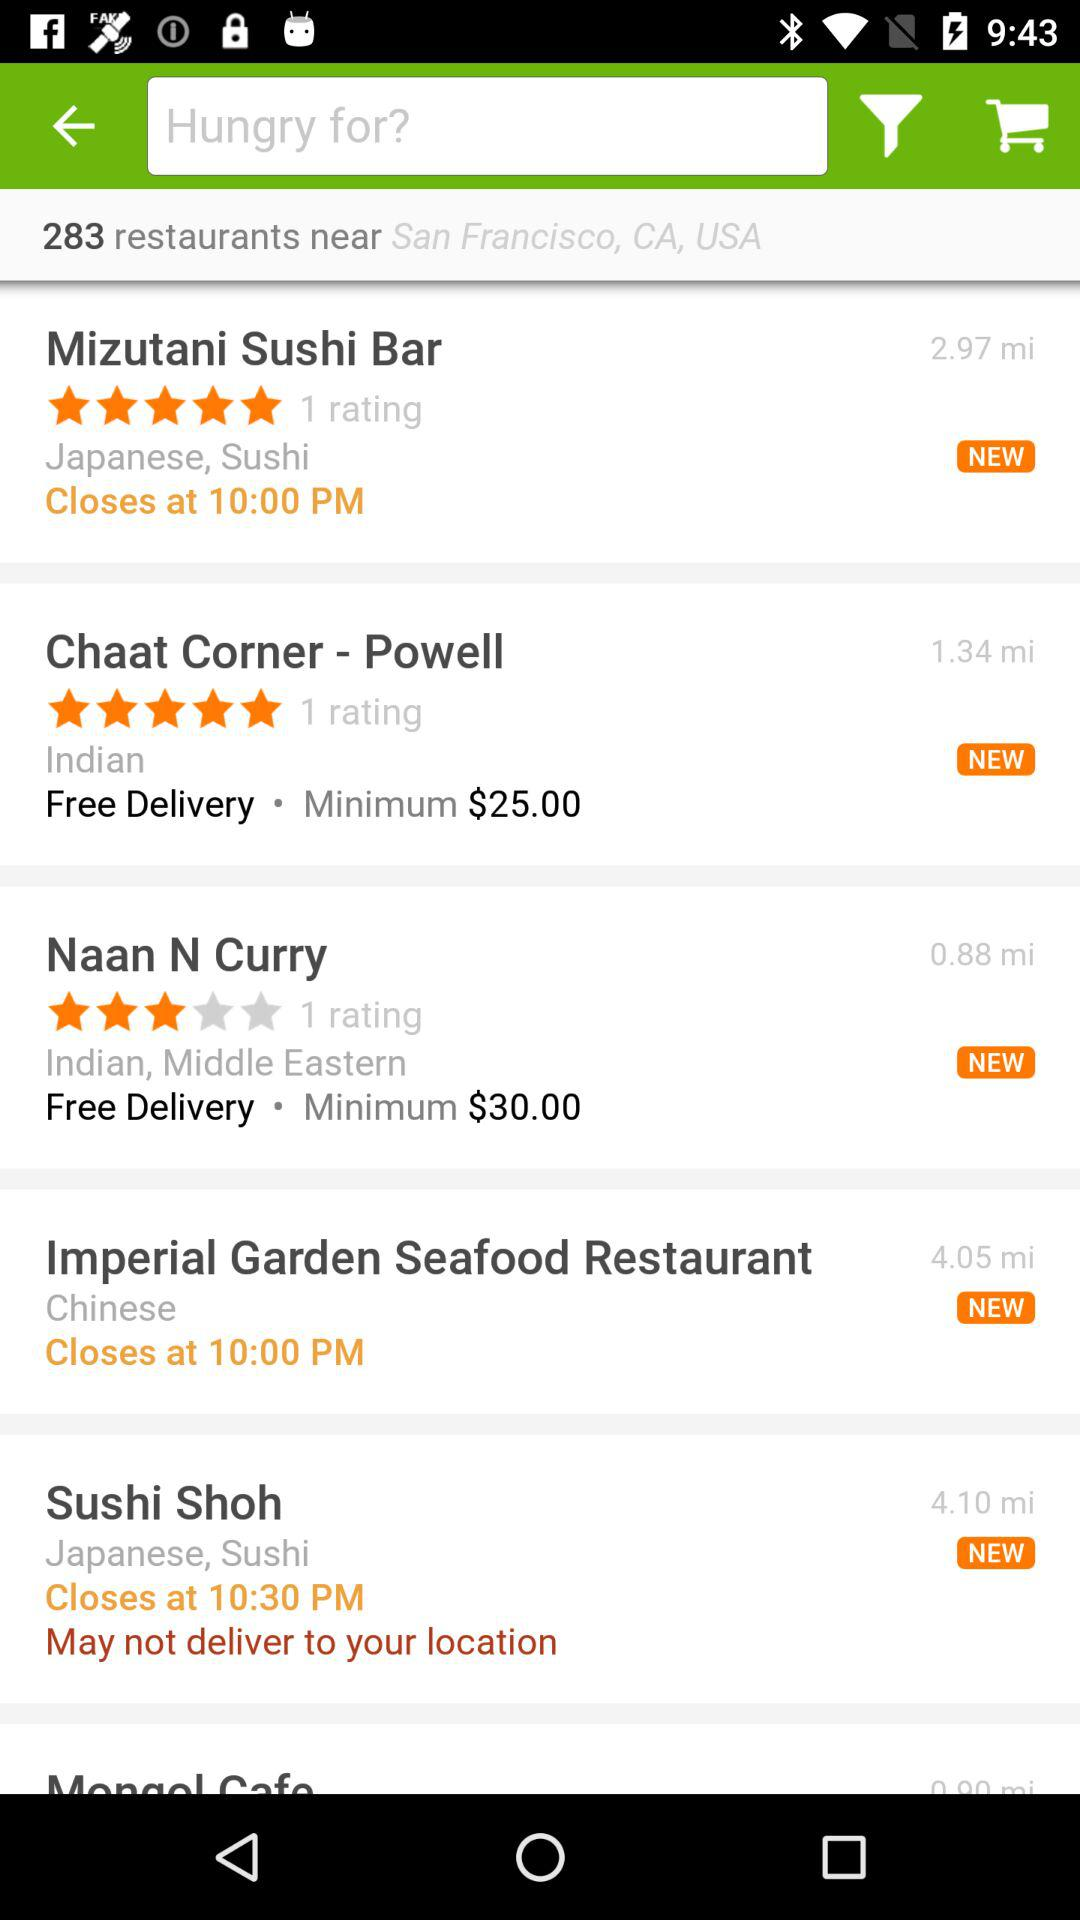What is the minimum order value for "Naan N Curry" for free delivery? The minimum order value is $30. 